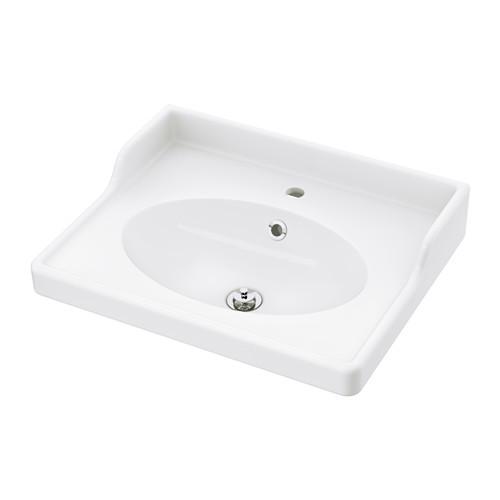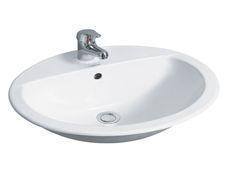The first image is the image on the left, the second image is the image on the right. For the images shown, is this caption "The basin in the image on the left is set into a counter." true? Answer yes or no. No. The first image is the image on the left, the second image is the image on the right. Assess this claim about the two images: "One sink has a white rectangular recessed bowl and no faucet or spout mounted to it.". Correct or not? Answer yes or no. No. 